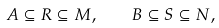<formula> <loc_0><loc_0><loc_500><loc_500>A \subseteq R \subseteq M , \quad B \subseteq S \subseteq N ,</formula> 